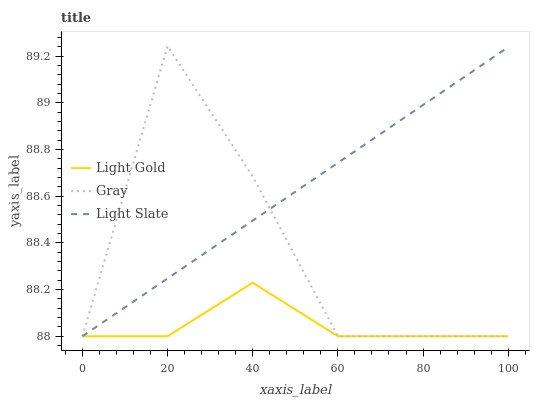Does Light Gold have the minimum area under the curve?
Answer yes or no. Yes. Does Light Slate have the maximum area under the curve?
Answer yes or no. Yes. Does Gray have the minimum area under the curve?
Answer yes or no. No. Does Gray have the maximum area under the curve?
Answer yes or no. No. Is Light Slate the smoothest?
Answer yes or no. Yes. Is Gray the roughest?
Answer yes or no. Yes. Is Light Gold the smoothest?
Answer yes or no. No. Is Light Gold the roughest?
Answer yes or no. No. Does Light Slate have the lowest value?
Answer yes or no. Yes. Does Gray have the highest value?
Answer yes or no. Yes. Does Light Gold have the highest value?
Answer yes or no. No. Does Light Slate intersect Gray?
Answer yes or no. Yes. Is Light Slate less than Gray?
Answer yes or no. No. Is Light Slate greater than Gray?
Answer yes or no. No. 